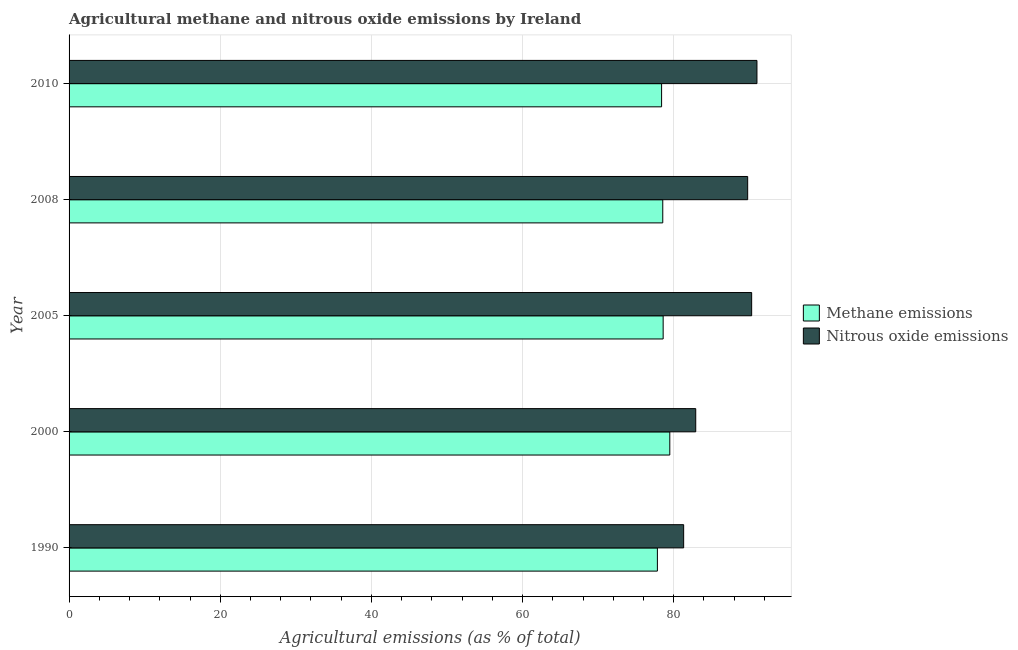How many different coloured bars are there?
Your answer should be compact. 2. How many bars are there on the 5th tick from the bottom?
Your answer should be very brief. 2. What is the label of the 2nd group of bars from the top?
Make the answer very short. 2008. In how many cases, is the number of bars for a given year not equal to the number of legend labels?
Your answer should be very brief. 0. What is the amount of nitrous oxide emissions in 2000?
Keep it short and to the point. 82.91. Across all years, what is the maximum amount of nitrous oxide emissions?
Give a very brief answer. 91.01. Across all years, what is the minimum amount of methane emissions?
Provide a succinct answer. 77.83. In which year was the amount of nitrous oxide emissions minimum?
Your answer should be compact. 1990. What is the total amount of nitrous oxide emissions in the graph?
Offer a terse response. 435.31. What is the difference between the amount of methane emissions in 2005 and that in 2010?
Offer a very short reply. 0.21. What is the difference between the amount of methane emissions in 2008 and the amount of nitrous oxide emissions in 2010?
Your answer should be compact. -12.46. What is the average amount of methane emissions per year?
Offer a very short reply. 78.57. In the year 1990, what is the difference between the amount of methane emissions and amount of nitrous oxide emissions?
Your answer should be compact. -3.48. In how many years, is the amount of nitrous oxide emissions greater than 80 %?
Make the answer very short. 5. What is the ratio of the amount of nitrous oxide emissions in 1990 to that in 2008?
Your answer should be compact. 0.91. Is the amount of nitrous oxide emissions in 2000 less than that in 2005?
Offer a terse response. Yes. What is the difference between the highest and the second highest amount of methane emissions?
Ensure brevity in your answer.  0.88. What does the 2nd bar from the top in 2005 represents?
Provide a short and direct response. Methane emissions. What does the 2nd bar from the bottom in 2008 represents?
Keep it short and to the point. Nitrous oxide emissions. Where does the legend appear in the graph?
Your response must be concise. Center right. How are the legend labels stacked?
Keep it short and to the point. Vertical. What is the title of the graph?
Your answer should be very brief. Agricultural methane and nitrous oxide emissions by Ireland. Does "Canada" appear as one of the legend labels in the graph?
Provide a short and direct response. No. What is the label or title of the X-axis?
Keep it short and to the point. Agricultural emissions (as % of total). What is the label or title of the Y-axis?
Provide a succinct answer. Year. What is the Agricultural emissions (as % of total) of Methane emissions in 1990?
Your answer should be compact. 77.83. What is the Agricultural emissions (as % of total) of Nitrous oxide emissions in 1990?
Make the answer very short. 81.31. What is the Agricultural emissions (as % of total) in Methane emissions in 2000?
Provide a short and direct response. 79.48. What is the Agricultural emissions (as % of total) of Nitrous oxide emissions in 2000?
Your answer should be very brief. 82.91. What is the Agricultural emissions (as % of total) in Methane emissions in 2005?
Provide a short and direct response. 78.6. What is the Agricultural emissions (as % of total) in Nitrous oxide emissions in 2005?
Give a very brief answer. 90.31. What is the Agricultural emissions (as % of total) in Methane emissions in 2008?
Give a very brief answer. 78.55. What is the Agricultural emissions (as % of total) of Nitrous oxide emissions in 2008?
Offer a terse response. 89.78. What is the Agricultural emissions (as % of total) of Methane emissions in 2010?
Your answer should be very brief. 78.39. What is the Agricultural emissions (as % of total) in Nitrous oxide emissions in 2010?
Your response must be concise. 91.01. Across all years, what is the maximum Agricultural emissions (as % of total) of Methane emissions?
Ensure brevity in your answer.  79.48. Across all years, what is the maximum Agricultural emissions (as % of total) in Nitrous oxide emissions?
Your answer should be very brief. 91.01. Across all years, what is the minimum Agricultural emissions (as % of total) of Methane emissions?
Provide a short and direct response. 77.83. Across all years, what is the minimum Agricultural emissions (as % of total) in Nitrous oxide emissions?
Offer a terse response. 81.31. What is the total Agricultural emissions (as % of total) of Methane emissions in the graph?
Offer a terse response. 392.85. What is the total Agricultural emissions (as % of total) in Nitrous oxide emissions in the graph?
Offer a terse response. 435.31. What is the difference between the Agricultural emissions (as % of total) of Methane emissions in 1990 and that in 2000?
Offer a terse response. -1.64. What is the difference between the Agricultural emissions (as % of total) in Nitrous oxide emissions in 1990 and that in 2000?
Your answer should be very brief. -1.6. What is the difference between the Agricultural emissions (as % of total) in Methane emissions in 1990 and that in 2005?
Provide a short and direct response. -0.76. What is the difference between the Agricultural emissions (as % of total) of Nitrous oxide emissions in 1990 and that in 2005?
Offer a terse response. -9. What is the difference between the Agricultural emissions (as % of total) in Methane emissions in 1990 and that in 2008?
Offer a terse response. -0.71. What is the difference between the Agricultural emissions (as % of total) of Nitrous oxide emissions in 1990 and that in 2008?
Make the answer very short. -8.47. What is the difference between the Agricultural emissions (as % of total) of Methane emissions in 1990 and that in 2010?
Your answer should be very brief. -0.56. What is the difference between the Agricultural emissions (as % of total) of Nitrous oxide emissions in 1990 and that in 2010?
Ensure brevity in your answer.  -9.7. What is the difference between the Agricultural emissions (as % of total) of Methane emissions in 2000 and that in 2005?
Provide a short and direct response. 0.88. What is the difference between the Agricultural emissions (as % of total) in Nitrous oxide emissions in 2000 and that in 2005?
Make the answer very short. -7.4. What is the difference between the Agricultural emissions (as % of total) of Methane emissions in 2000 and that in 2008?
Provide a short and direct response. 0.93. What is the difference between the Agricultural emissions (as % of total) in Nitrous oxide emissions in 2000 and that in 2008?
Keep it short and to the point. -6.87. What is the difference between the Agricultural emissions (as % of total) in Methane emissions in 2000 and that in 2010?
Your answer should be very brief. 1.08. What is the difference between the Agricultural emissions (as % of total) in Nitrous oxide emissions in 2000 and that in 2010?
Give a very brief answer. -8.1. What is the difference between the Agricultural emissions (as % of total) of Methane emissions in 2005 and that in 2008?
Make the answer very short. 0.05. What is the difference between the Agricultural emissions (as % of total) of Nitrous oxide emissions in 2005 and that in 2008?
Your answer should be very brief. 0.53. What is the difference between the Agricultural emissions (as % of total) in Methane emissions in 2005 and that in 2010?
Provide a succinct answer. 0.21. What is the difference between the Agricultural emissions (as % of total) of Nitrous oxide emissions in 2005 and that in 2010?
Your answer should be compact. -0.7. What is the difference between the Agricultural emissions (as % of total) in Methane emissions in 2008 and that in 2010?
Your response must be concise. 0.15. What is the difference between the Agricultural emissions (as % of total) in Nitrous oxide emissions in 2008 and that in 2010?
Offer a very short reply. -1.23. What is the difference between the Agricultural emissions (as % of total) of Methane emissions in 1990 and the Agricultural emissions (as % of total) of Nitrous oxide emissions in 2000?
Provide a short and direct response. -5.07. What is the difference between the Agricultural emissions (as % of total) of Methane emissions in 1990 and the Agricultural emissions (as % of total) of Nitrous oxide emissions in 2005?
Your response must be concise. -12.47. What is the difference between the Agricultural emissions (as % of total) in Methane emissions in 1990 and the Agricultural emissions (as % of total) in Nitrous oxide emissions in 2008?
Offer a terse response. -11.95. What is the difference between the Agricultural emissions (as % of total) in Methane emissions in 1990 and the Agricultural emissions (as % of total) in Nitrous oxide emissions in 2010?
Offer a very short reply. -13.17. What is the difference between the Agricultural emissions (as % of total) of Methane emissions in 2000 and the Agricultural emissions (as % of total) of Nitrous oxide emissions in 2005?
Your answer should be compact. -10.83. What is the difference between the Agricultural emissions (as % of total) of Methane emissions in 2000 and the Agricultural emissions (as % of total) of Nitrous oxide emissions in 2008?
Provide a succinct answer. -10.3. What is the difference between the Agricultural emissions (as % of total) of Methane emissions in 2000 and the Agricultural emissions (as % of total) of Nitrous oxide emissions in 2010?
Keep it short and to the point. -11.53. What is the difference between the Agricultural emissions (as % of total) of Methane emissions in 2005 and the Agricultural emissions (as % of total) of Nitrous oxide emissions in 2008?
Your response must be concise. -11.18. What is the difference between the Agricultural emissions (as % of total) of Methane emissions in 2005 and the Agricultural emissions (as % of total) of Nitrous oxide emissions in 2010?
Offer a terse response. -12.41. What is the difference between the Agricultural emissions (as % of total) of Methane emissions in 2008 and the Agricultural emissions (as % of total) of Nitrous oxide emissions in 2010?
Ensure brevity in your answer.  -12.46. What is the average Agricultural emissions (as % of total) in Methane emissions per year?
Your response must be concise. 78.57. What is the average Agricultural emissions (as % of total) of Nitrous oxide emissions per year?
Offer a very short reply. 87.06. In the year 1990, what is the difference between the Agricultural emissions (as % of total) in Methane emissions and Agricultural emissions (as % of total) in Nitrous oxide emissions?
Ensure brevity in your answer.  -3.48. In the year 2000, what is the difference between the Agricultural emissions (as % of total) in Methane emissions and Agricultural emissions (as % of total) in Nitrous oxide emissions?
Give a very brief answer. -3.43. In the year 2005, what is the difference between the Agricultural emissions (as % of total) of Methane emissions and Agricultural emissions (as % of total) of Nitrous oxide emissions?
Provide a short and direct response. -11.71. In the year 2008, what is the difference between the Agricultural emissions (as % of total) of Methane emissions and Agricultural emissions (as % of total) of Nitrous oxide emissions?
Ensure brevity in your answer.  -11.23. In the year 2010, what is the difference between the Agricultural emissions (as % of total) in Methane emissions and Agricultural emissions (as % of total) in Nitrous oxide emissions?
Make the answer very short. -12.62. What is the ratio of the Agricultural emissions (as % of total) of Methane emissions in 1990 to that in 2000?
Offer a very short reply. 0.98. What is the ratio of the Agricultural emissions (as % of total) in Nitrous oxide emissions in 1990 to that in 2000?
Ensure brevity in your answer.  0.98. What is the ratio of the Agricultural emissions (as % of total) in Methane emissions in 1990 to that in 2005?
Keep it short and to the point. 0.99. What is the ratio of the Agricultural emissions (as % of total) of Nitrous oxide emissions in 1990 to that in 2005?
Provide a short and direct response. 0.9. What is the ratio of the Agricultural emissions (as % of total) in Methane emissions in 1990 to that in 2008?
Your answer should be compact. 0.99. What is the ratio of the Agricultural emissions (as % of total) in Nitrous oxide emissions in 1990 to that in 2008?
Ensure brevity in your answer.  0.91. What is the ratio of the Agricultural emissions (as % of total) of Nitrous oxide emissions in 1990 to that in 2010?
Provide a short and direct response. 0.89. What is the ratio of the Agricultural emissions (as % of total) in Methane emissions in 2000 to that in 2005?
Ensure brevity in your answer.  1.01. What is the ratio of the Agricultural emissions (as % of total) of Nitrous oxide emissions in 2000 to that in 2005?
Your answer should be very brief. 0.92. What is the ratio of the Agricultural emissions (as % of total) of Methane emissions in 2000 to that in 2008?
Provide a succinct answer. 1.01. What is the ratio of the Agricultural emissions (as % of total) in Nitrous oxide emissions in 2000 to that in 2008?
Ensure brevity in your answer.  0.92. What is the ratio of the Agricultural emissions (as % of total) in Methane emissions in 2000 to that in 2010?
Make the answer very short. 1.01. What is the ratio of the Agricultural emissions (as % of total) in Nitrous oxide emissions in 2000 to that in 2010?
Offer a terse response. 0.91. What is the ratio of the Agricultural emissions (as % of total) in Methane emissions in 2005 to that in 2008?
Your answer should be compact. 1. What is the ratio of the Agricultural emissions (as % of total) in Nitrous oxide emissions in 2005 to that in 2008?
Make the answer very short. 1.01. What is the ratio of the Agricultural emissions (as % of total) in Methane emissions in 2005 to that in 2010?
Offer a very short reply. 1. What is the ratio of the Agricultural emissions (as % of total) of Methane emissions in 2008 to that in 2010?
Provide a succinct answer. 1. What is the ratio of the Agricultural emissions (as % of total) of Nitrous oxide emissions in 2008 to that in 2010?
Your response must be concise. 0.99. What is the difference between the highest and the second highest Agricultural emissions (as % of total) in Methane emissions?
Ensure brevity in your answer.  0.88. What is the difference between the highest and the second highest Agricultural emissions (as % of total) in Nitrous oxide emissions?
Your answer should be very brief. 0.7. What is the difference between the highest and the lowest Agricultural emissions (as % of total) of Methane emissions?
Your response must be concise. 1.64. What is the difference between the highest and the lowest Agricultural emissions (as % of total) in Nitrous oxide emissions?
Offer a very short reply. 9.7. 